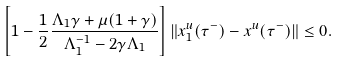<formula> <loc_0><loc_0><loc_500><loc_500>\left [ 1 - \frac { 1 } { 2 } \frac { \Lambda _ { 1 } \gamma + \mu ( 1 + \gamma ) } { \Lambda ^ { - 1 } _ { 1 } - 2 \gamma \Lambda _ { 1 } } \right ] \| x ^ { u } _ { 1 } ( \tau ^ { - } ) - x ^ { u } ( \tau ^ { - } ) \| \leq 0 .</formula> 